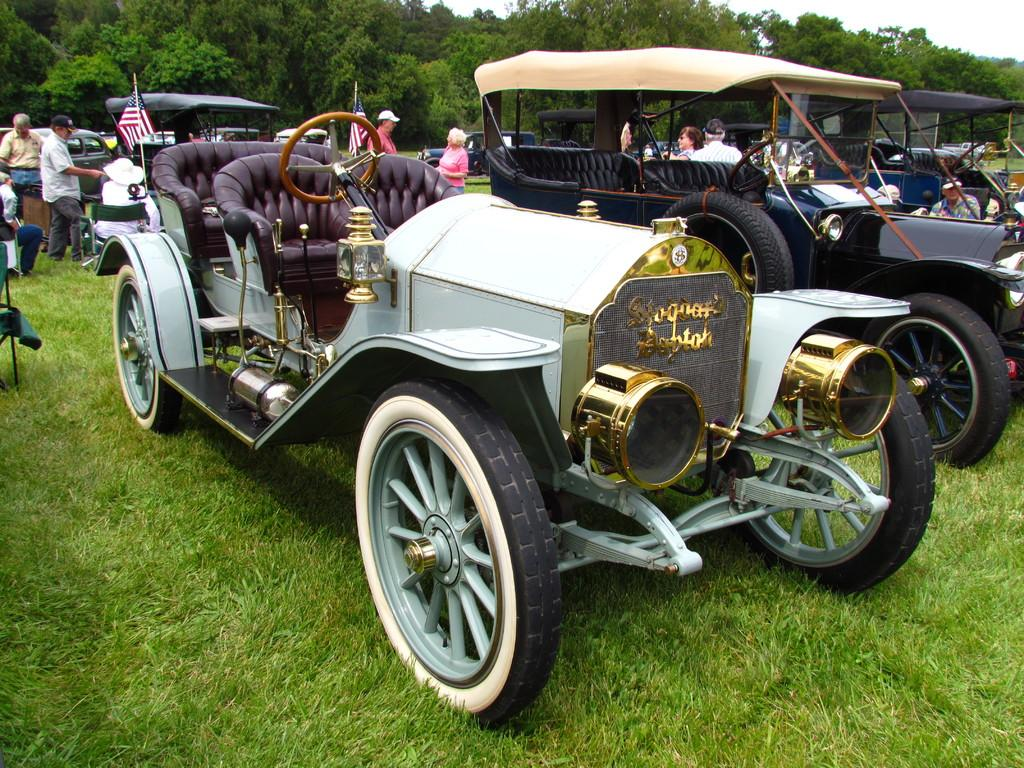What type of objects can be seen in the garden in the image? There are vehicles in the garden in the image. Can you describe the appearance of the vehicles? The vehicles are in different colors. What else can be seen in the image besides the vehicles? There are flags visible in the image, and there are people present in the image. What is visible in the background of the image? Trees are visible in the background of the image. Where is the kitten playing with the camera in the image? There is no kitten or camera present in the image. Can you tell me how many sinks are visible in the image? There are no sinks visible in the image. 